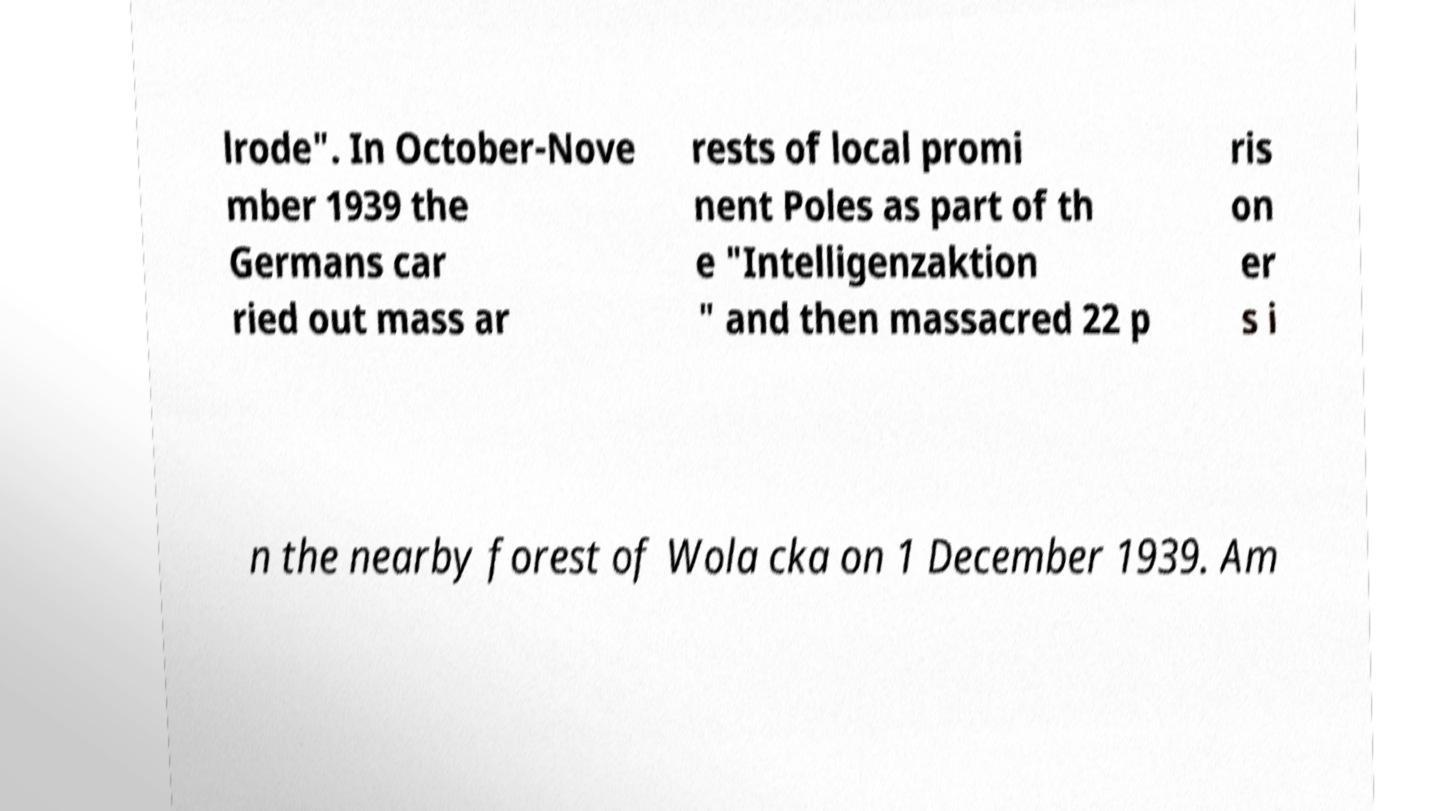Can you read and provide the text displayed in the image?This photo seems to have some interesting text. Can you extract and type it out for me? lrode". In October-Nove mber 1939 the Germans car ried out mass ar rests of local promi nent Poles as part of th e "Intelligenzaktion " and then massacred 22 p ris on er s i n the nearby forest of Wola cka on 1 December 1939. Am 